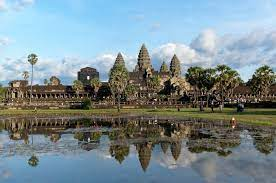What could be the daily life like for the people who built this temple? The daily life of the people who built Angkor Wat was likely rigorous and structured. Skilled artisans and laborers would have worked from dawn to dusk, cutting and transporting massive stones, carving intricate designs, and constructing grand structures under the supervision of master architects. The nearby townships would have been bustling with activity, with workers participating in various trades to support the construction, from metalwork to transporting materials. Religious rituals and offerings would be a significant part of their lives, seeking blessings for the monumental task. Festivals and ceremonies would mark key construction milestones, fostering a sense of community and shared purpose. Could you imagine what kind of festivals they might celebrate within the temple grounds? Within the temple grounds, grand festivals celebrating gods and celestial events would take place, with vibrant processions, traditional dances, and elaborate offerings. The Festival of Vishnu might involve a reenactment of mythological tales, with priests and dancers dressed in ornate costumes, bringing the stories to life amidst the temple’s stone carvings. Another significant celebration could be the Harvest Festival, where the community would gather to give thanks for the bounty and seek blessings for the next cycle. The air would fill with the sounds of traditional music, and the grounds would be adorned with colorful decorations and fragrant flowers. Such festivals would foster a deep sense of spirituality and community amongst the people. Imagine there is an alternate history where Angkor Wat served a different purpose. What could it be? In an alternate history, imagine Angkor Wat as not just a religious temple but as a grand astronomical observatory. The intricate carvings on the temple walls would serve as celestial maps, depicting the movements of stars and planets. The central spire, reaching towards the heavens, would be a massive telescope, aligned perfectly with the cardinal directions to observe celestial events. Scholars and astronomers from across the ancient world would gather here, sharing knowledge and advancing the understanding of the cosmos. Each chamber within the temple could represent different constellations, and the reflection pool in front of the temple would be used to study the night sky. This alternative history would make Angkor Wat a beacon of ancient scientific thought and discovery, blending spirituality with the quest for cosmic knowledge. 